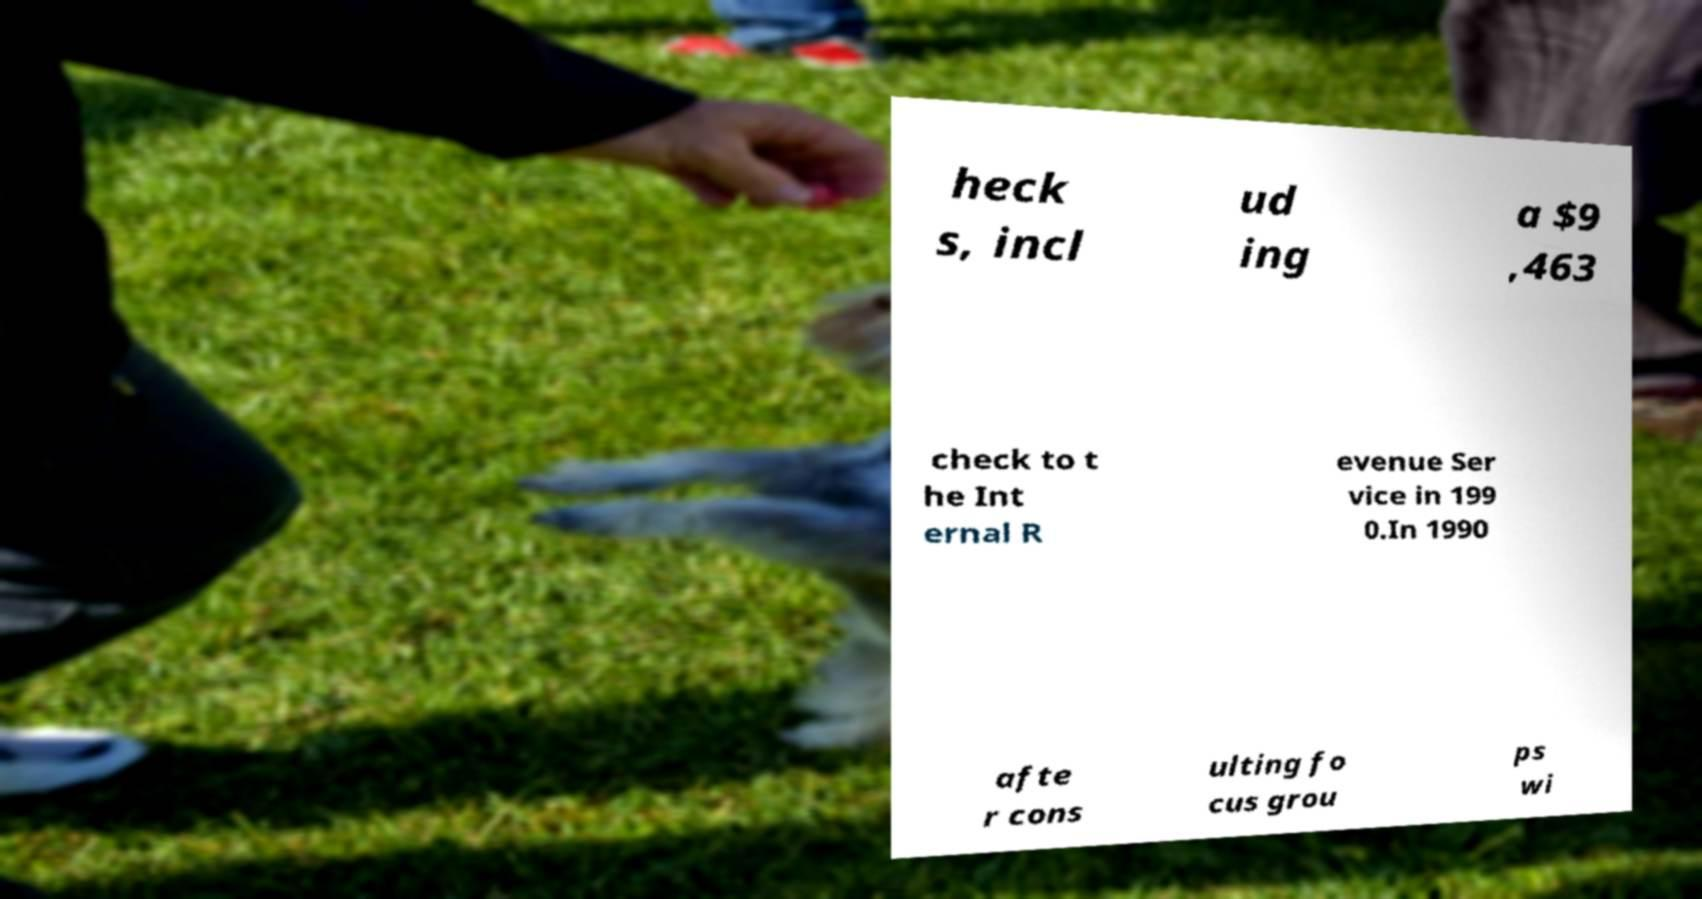Can you accurately transcribe the text from the provided image for me? heck s, incl ud ing a $9 ,463 check to t he Int ernal R evenue Ser vice in 199 0.In 1990 afte r cons ulting fo cus grou ps wi 